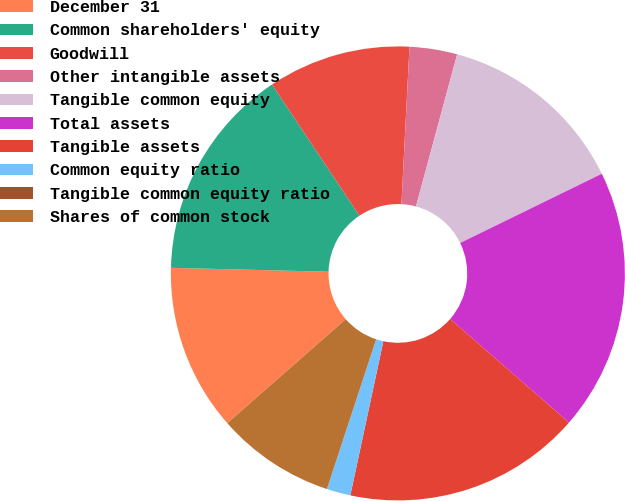Convert chart to OTSL. <chart><loc_0><loc_0><loc_500><loc_500><pie_chart><fcel>December 31<fcel>Common shareholders' equity<fcel>Goodwill<fcel>Other intangible assets<fcel>Tangible common equity<fcel>Total assets<fcel>Tangible assets<fcel>Common equity ratio<fcel>Tangible common equity ratio<fcel>Shares of common stock<nl><fcel>11.86%<fcel>15.25%<fcel>10.17%<fcel>3.39%<fcel>13.56%<fcel>18.64%<fcel>16.95%<fcel>1.7%<fcel>0.0%<fcel>8.47%<nl></chart> 